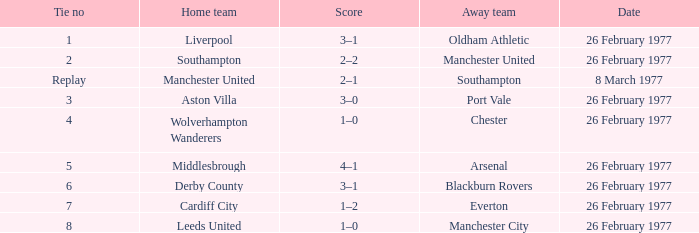What's the score when the tie number was replay? 2–1. 